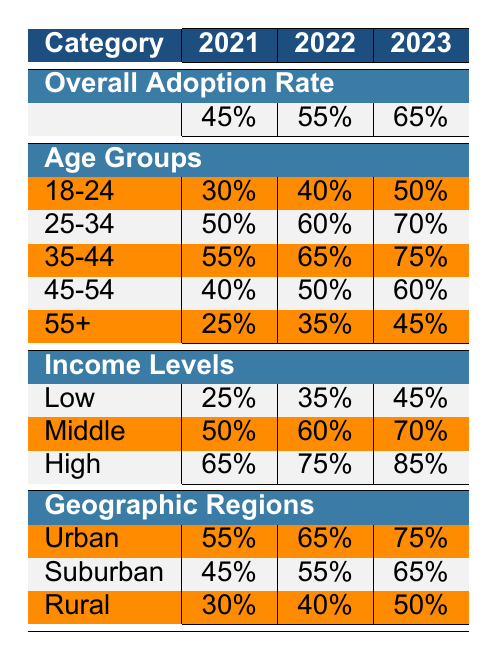What was the overall digital mortgage adoption rate in 2022? Looking at the table under the "Overall Adoption Rate" section, the value for 2022 is clearly shown as 55%.
Answer: 55% Which age group had the highest adoption rate in 2023? Reviewing the "Age Groups" section, the adoption rates in 2023 are: 18-24 (50%), 25-34 (70%), 35-44 (75%), 45-54 (60%), and 55+ (45%). The highest rate is 75% for the 35-44 age group.
Answer: 35-44 What is the average digital mortgage adoption rate for the "Low" income group over the three years? To calculate the average for the "Low" income group, sum the rates for the years 2021 (25%), 2022 (35%), and 2023 (45%), which equals (25 + 35 + 45) = 105. Then divide by 3 to get the average: 105 / 3 = 35%.
Answer: 35% Did the adoption rate for the "Urban" geographic region increase from 2021 to 2023? The table shows the adoption rates for Urban as 55% in 2021 and 75% in 2023. Since 75% is greater than 55%, the adoption rate did increase.
Answer: Yes Which demographic had an adoption rate of 45% in 2023? Looking at the table, the "High" income level in 2023 has an adoption rate of 85%, while the adoption rate for "Low" income is 45%. Therefore, the "Low" income group is the one with this rate.
Answer: Low 